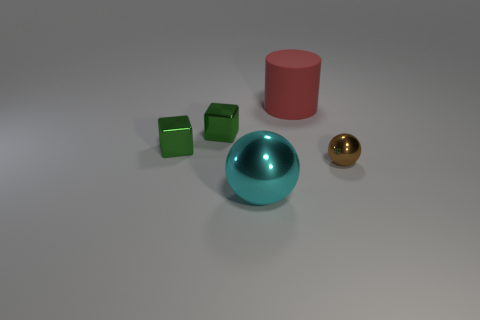Add 3 gray matte things. How many objects exist? 8 Subtract all brown spheres. How many spheres are left? 1 Subtract all blocks. How many objects are left? 3 Subtract 1 cubes. How many cubes are left? 1 Subtract all small green metallic blocks. Subtract all big cyan spheres. How many objects are left? 2 Add 3 big rubber things. How many big rubber things are left? 4 Add 1 rubber cylinders. How many rubber cylinders exist? 2 Subtract 0 blue spheres. How many objects are left? 5 Subtract all green spheres. Subtract all gray cylinders. How many spheres are left? 2 